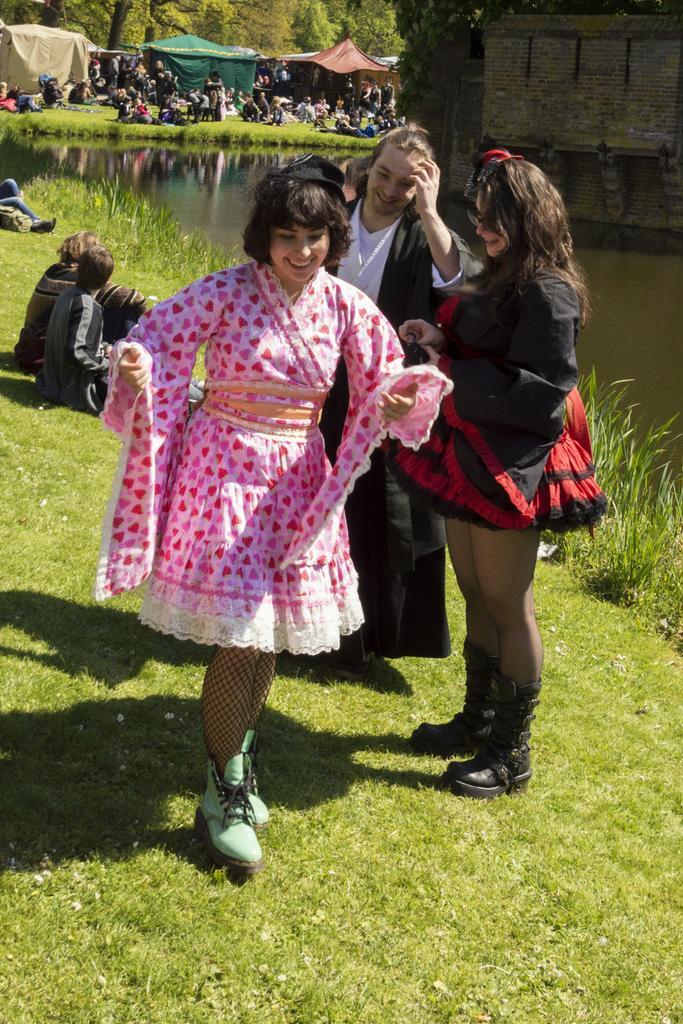Can you describe this image briefly? In this picture I can see a woman in the middle, she is smiling, beside her there are two persons, on the right side I can see the water and the wall. In the background there are people and also I can see few tents and trees. 